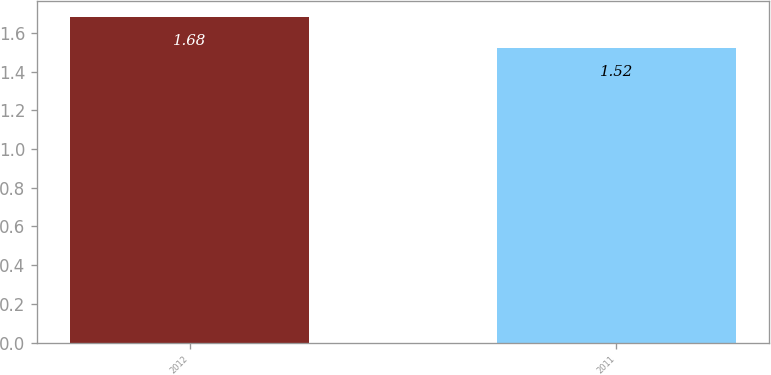<chart> <loc_0><loc_0><loc_500><loc_500><bar_chart><fcel>2012<fcel>2011<nl><fcel>1.68<fcel>1.52<nl></chart> 